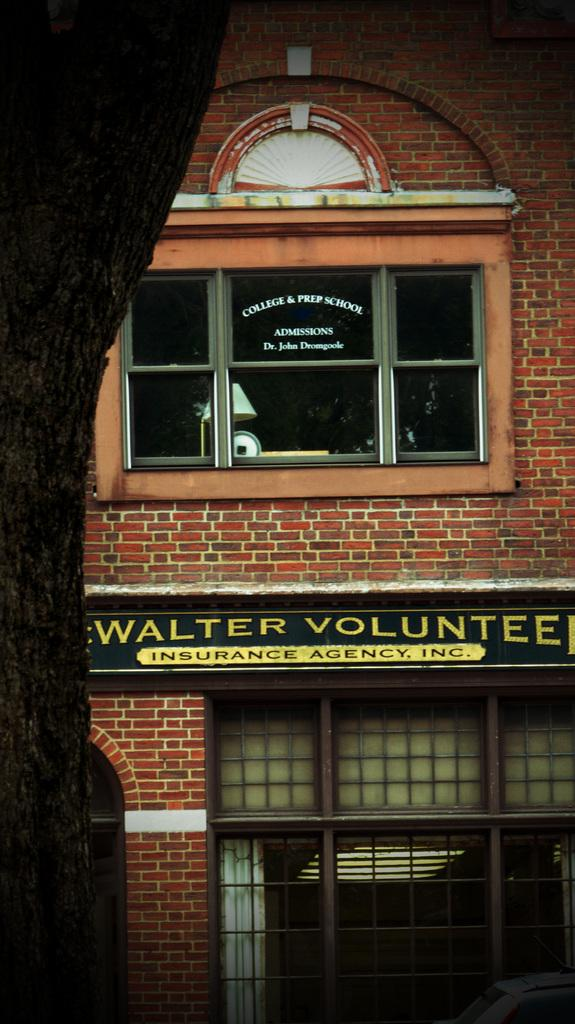What type of material is used for the windows in the image? The windows in the image are made of glass. What can be seen on the board in the image? Unfortunately, the facts provided do not give any information about what is on the board. Can you describe the board in the image? The board is visible in the image, but the facts do not provide any details about its size, shape, or color. What color is the badge on the board in the image? There is no badge present on the board in the image. What effect does the board have on the glass windows in the image? The facts provided do not give any information about the board's effect on the glass windows. 